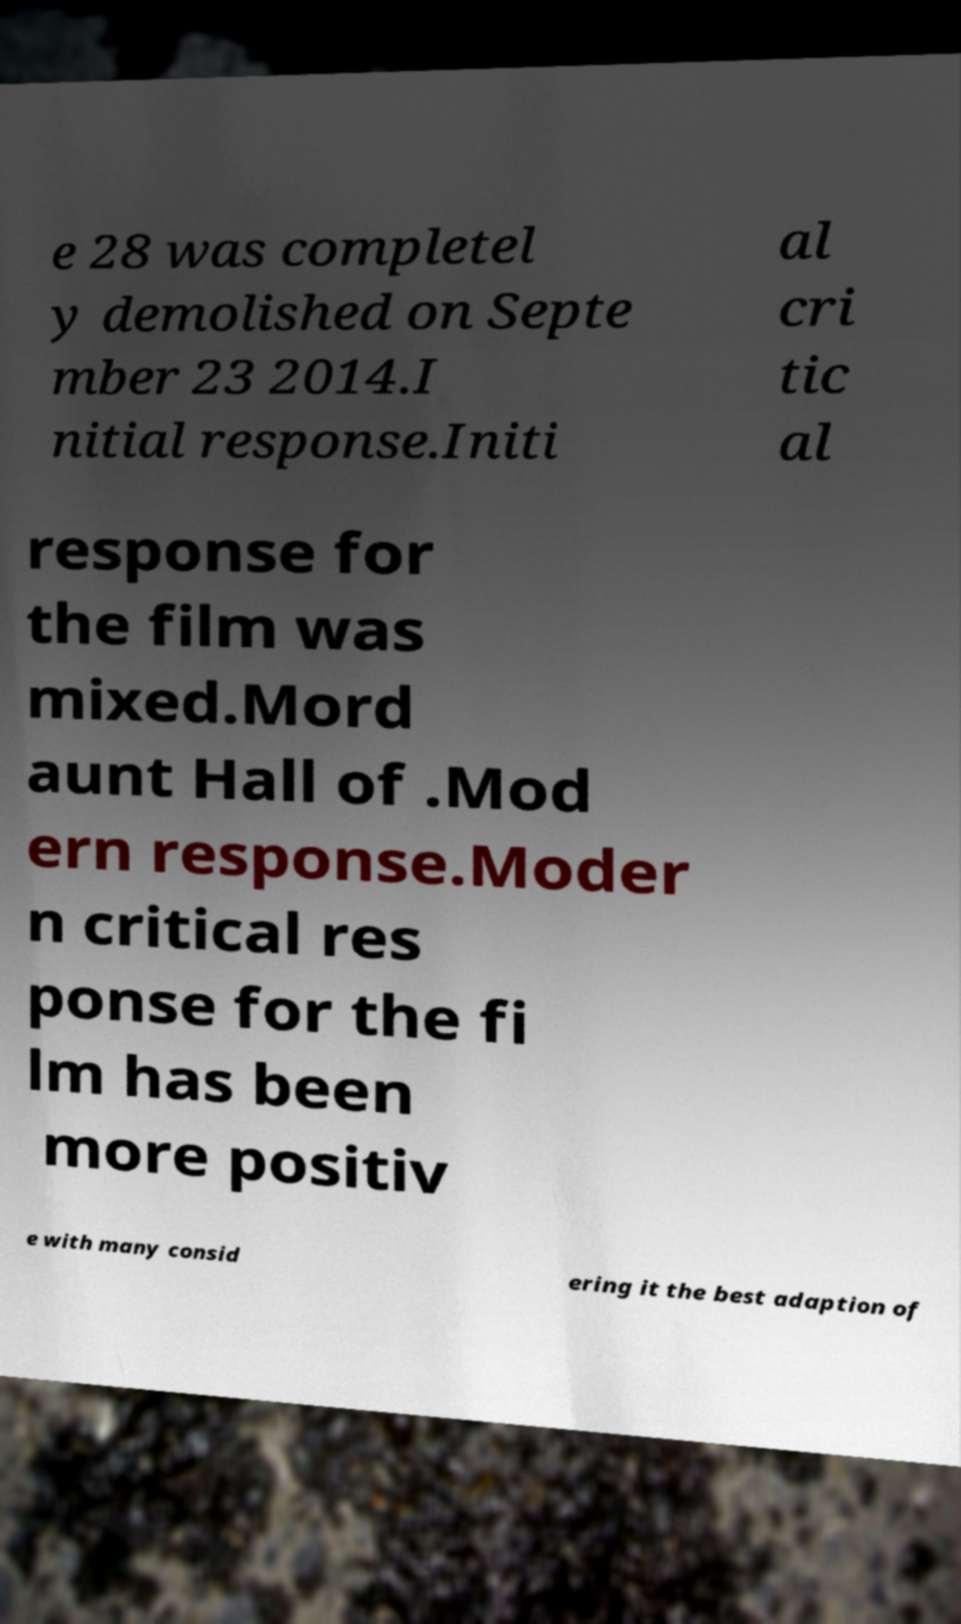What messages or text are displayed in this image? I need them in a readable, typed format. e 28 was completel y demolished on Septe mber 23 2014.I nitial response.Initi al cri tic al response for the film was mixed.Mord aunt Hall of .Mod ern response.Moder n critical res ponse for the fi lm has been more positiv e with many consid ering it the best adaption of 